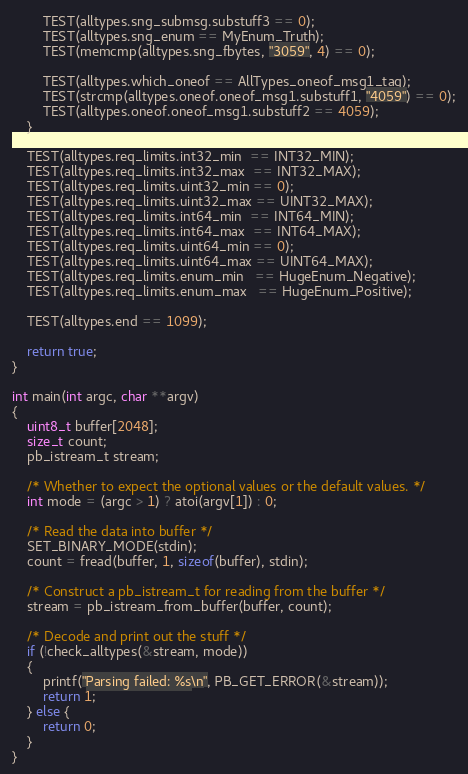Convert code to text. <code><loc_0><loc_0><loc_500><loc_500><_C_>        TEST(alltypes.sng_submsg.substuff3 == 0);
        TEST(alltypes.sng_enum == MyEnum_Truth);
        TEST(memcmp(alltypes.sng_fbytes, "3059", 4) == 0);

        TEST(alltypes.which_oneof == AllTypes_oneof_msg1_tag);
        TEST(strcmp(alltypes.oneof.oneof_msg1.substuff1, "4059") == 0);
        TEST(alltypes.oneof.oneof_msg1.substuff2 == 4059);
    }

    TEST(alltypes.req_limits.int32_min  == INT32_MIN);
    TEST(alltypes.req_limits.int32_max  == INT32_MAX);
    TEST(alltypes.req_limits.uint32_min == 0);
    TEST(alltypes.req_limits.uint32_max == UINT32_MAX);
    TEST(alltypes.req_limits.int64_min  == INT64_MIN);
    TEST(alltypes.req_limits.int64_max  == INT64_MAX);
    TEST(alltypes.req_limits.uint64_min == 0);
    TEST(alltypes.req_limits.uint64_max == UINT64_MAX);
    TEST(alltypes.req_limits.enum_min   == HugeEnum_Negative);
    TEST(alltypes.req_limits.enum_max   == HugeEnum_Positive);

    TEST(alltypes.end == 1099);

    return true;
}

int main(int argc, char **argv)
{
    uint8_t buffer[2048];
    size_t count;
    pb_istream_t stream;

    /* Whether to expect the optional values or the default values. */
    int mode = (argc > 1) ? atoi(argv[1]) : 0;

    /* Read the data into buffer */
    SET_BINARY_MODE(stdin);
    count = fread(buffer, 1, sizeof(buffer), stdin);

    /* Construct a pb_istream_t for reading from the buffer */
    stream = pb_istream_from_buffer(buffer, count);

    /* Decode and print out the stuff */
    if (!check_alltypes(&stream, mode))
    {
        printf("Parsing failed: %s\n", PB_GET_ERROR(&stream));
        return 1;
    } else {
        return 0;
    }
}
</code> 